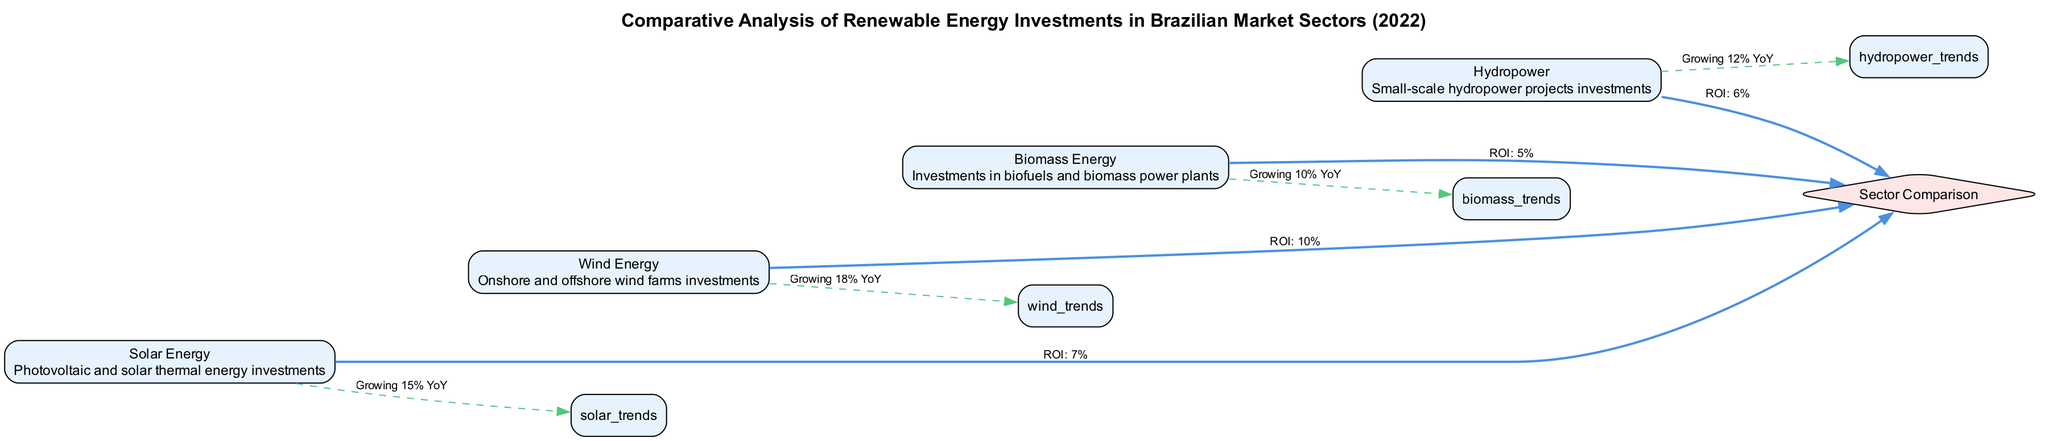What is the ROI for solar energy investments? The diagram indicates that the ROI for solar energy investments can be found in the edge connecting solar energy to the sector comparison node. According to the label of that edge, the ROI is 7%.
Answer: 7% Which renewable energy sector has the highest year-over-year growth? To determine which sector has the highest growth, we can compare the year-over-year growth percentages provided in the edges leading to the trends nodes. According to the labels: solar energy grows 15%, wind energy grows 18%, biomass grows 10%, and hydropower grows 12%. The highest value is 18%, which corresponds to the wind energy sector.
Answer: Wind Energy How many renewable energy sectors are compared in this diagram? By counting the nodes that represent different energy sectors (solar, wind, biomass, hydropower), we find there are four distinct sectors depicted.
Answer: 4 What is the ROI for biomass energy investments? The ROI for biomass energy investments can be found in the edge connecting biomass energy to the sector comparison node. The label on that edge indicates that the ROI for biomass energy is 5%.
Answer: 5% Which sector has a lower ROI: hydropower or biomass energy? To answer this, we look at the ROI values for both hydropower (6%) and biomass energy (5%) found on their respective edges to the sector comparison node. Since 5% is less than 6%, biomass energy has a lower ROI than hydropower.
Answer: Biomass Energy What is the average ROI of the four renewable energy sectors? The ROIs provided are: solar energy 7%, wind energy 10%, biomass energy 5%, and hydropower 6%. To find the average, we sum these values (7 + 10 + 5 + 6 = 28) and divide by the number of sectors (4), resulting in an average ROI of 7%.
Answer: 7% Which energy sector is growing at 12% YoY? Referring to the growth trends labeled in the diagram, we see that hydropower has a year-over-year growth rate indicated as "Growing 12% YoY". Therefore, hydropower is the answer.
Answer: Hydropower What relationship is indicated between wind energy and sector comparison? The relationship from wind energy to the sector comparison node is specified by the edge which states that the ROI for wind energy investments is 10%.
Answer: ROI: 10% 